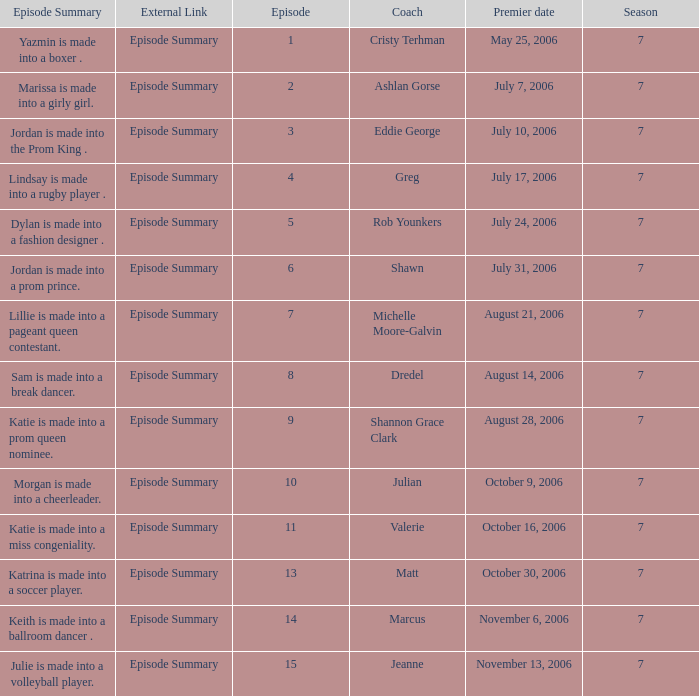How many episodes have a premier date of july 24, 2006 1.0. Could you parse the entire table as a dict? {'header': ['Episode Summary', 'External Link', 'Episode', 'Coach', 'Premier date', 'Season'], 'rows': [['Yazmin is made into a boxer .', 'Episode Summary', '1', 'Cristy Terhman', 'May 25, 2006', '7'], ['Marissa is made into a girly girl.', 'Episode Summary', '2', 'Ashlan Gorse', 'July 7, 2006', '7'], ['Jordan is made into the Prom King .', 'Episode Summary', '3', 'Eddie George', 'July 10, 2006', '7'], ['Lindsay is made into a rugby player .', 'Episode Summary', '4', 'Greg', 'July 17, 2006', '7'], ['Dylan is made into a fashion designer .', 'Episode Summary', '5', 'Rob Younkers', 'July 24, 2006', '7'], ['Jordan is made into a prom prince.', 'Episode Summary', '6', 'Shawn', 'July 31, 2006', '7'], ['Lillie is made into a pageant queen contestant.', 'Episode Summary', '7', 'Michelle Moore-Galvin', 'August 21, 2006', '7'], ['Sam is made into a break dancer.', 'Episode Summary', '8', 'Dredel', 'August 14, 2006', '7'], ['Katie is made into a prom queen nominee.', 'Episode Summary', '9', 'Shannon Grace Clark', 'August 28, 2006', '7'], ['Morgan is made into a cheerleader.', 'Episode Summary', '10', 'Julian', 'October 9, 2006', '7'], ['Katie is made into a miss congeniality.', 'Episode Summary', '11', 'Valerie', 'October 16, 2006', '7'], ['Katrina is made into a soccer player.', 'Episode Summary', '13', 'Matt', 'October 30, 2006', '7'], ['Keith is made into a ballroom dancer .', 'Episode Summary', '14', 'Marcus', 'November 6, 2006', '7'], ['Julie is made into a volleyball player.', 'Episode Summary', '15', 'Jeanne', 'November 13, 2006', '7']]} 